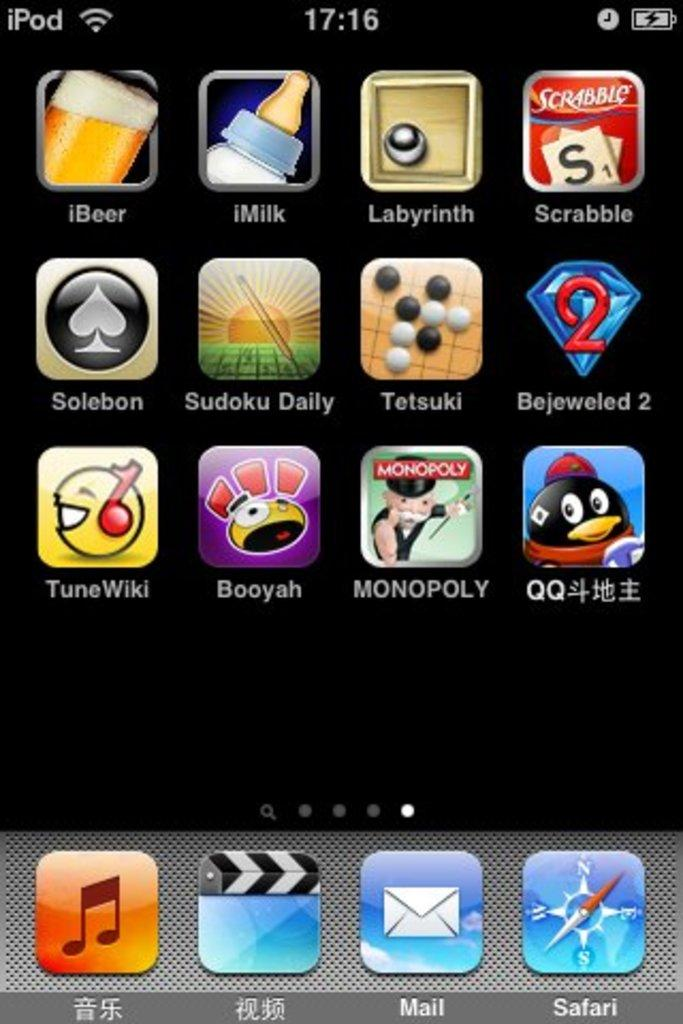Provide a one-sentence caption for the provided image. an iPod screen displaying multiple apps in English and Chinese. 